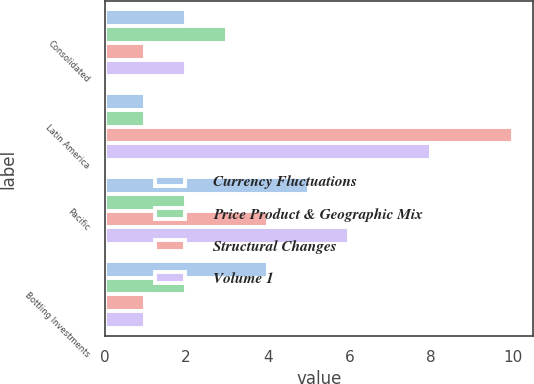Convert chart to OTSL. <chart><loc_0><loc_0><loc_500><loc_500><stacked_bar_chart><ecel><fcel>Consolidated<fcel>Latin America<fcel>Pacific<fcel>Bottling Investments<nl><fcel>Currency Fluctuations<fcel>2<fcel>1<fcel>5<fcel>4<nl><fcel>Price Product & Geographic Mix<fcel>3<fcel>1<fcel>2<fcel>2<nl><fcel>Structural Changes<fcel>1<fcel>10<fcel>4<fcel>1<nl><fcel>Volume 1<fcel>2<fcel>8<fcel>6<fcel>1<nl></chart> 